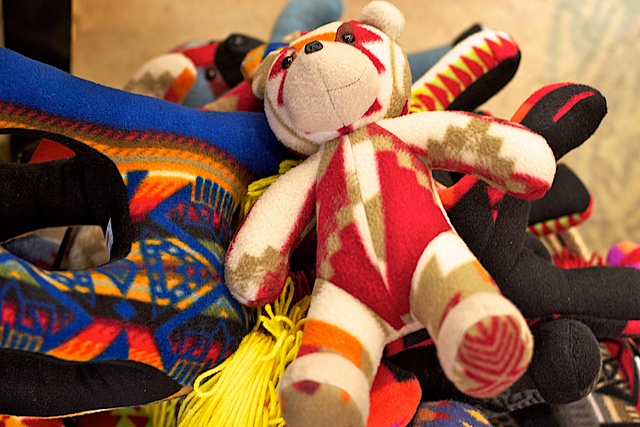Describe the objects in this image and their specific colors. I can see a teddy bear in maroon, tan, brown, and beige tones in this image. 